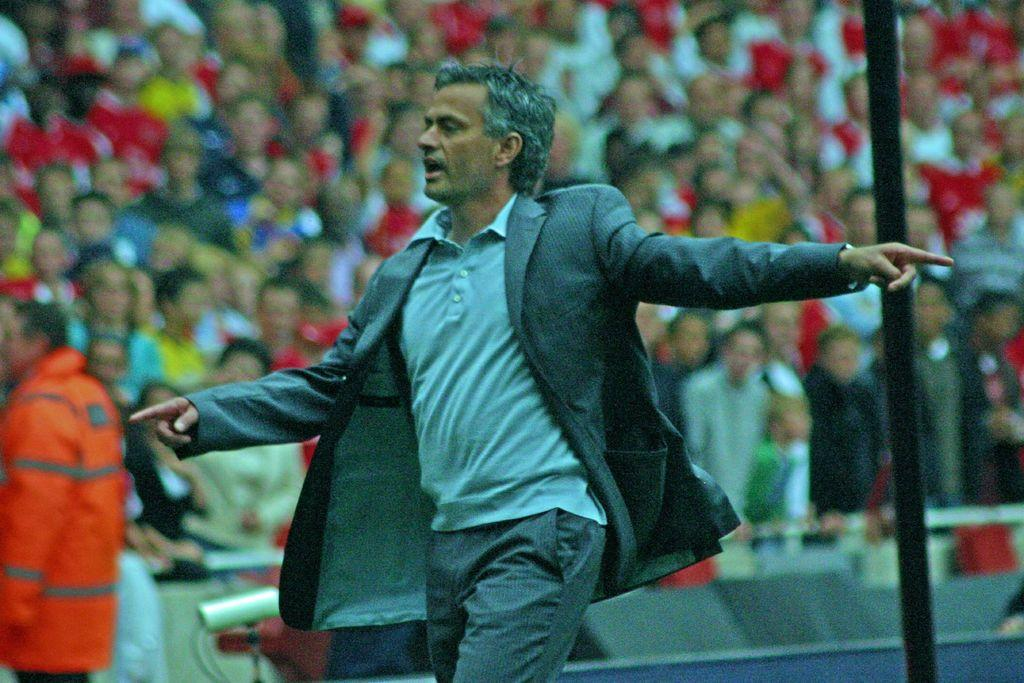How many people are in the image? There is a group of people in the image. What are the people in the group doing? The group of people is standing behind a person. What is the person walking and talking doing? The person walking and talking is likely having a conversation or giving a speech. What type of seed is being planted by the person walking and talking in the image? There is no seed or planting activity present in the image. 